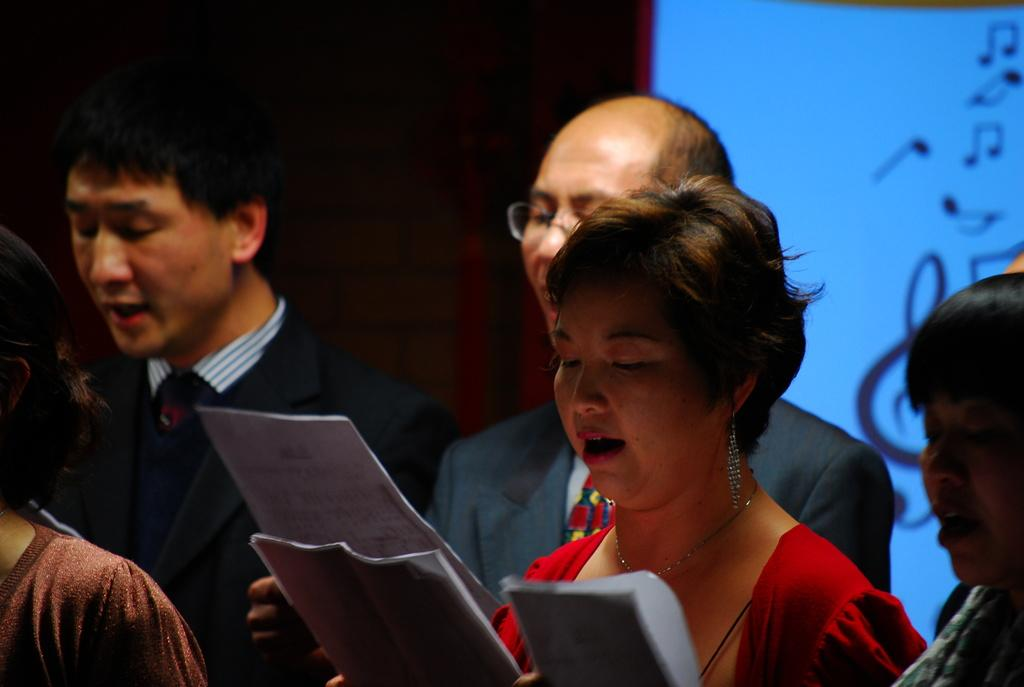What are the people in the image doing? The people in the image are standing and singing. What are the people holding in their hands? The people are holding papers. What can be seen on the screen in the image? The screen displays music symbols. What month is it in the image? The month cannot be determined from the image, as there is no information about the date or time. Are there any ghosts visible in the image? There are no ghosts present in the image. 